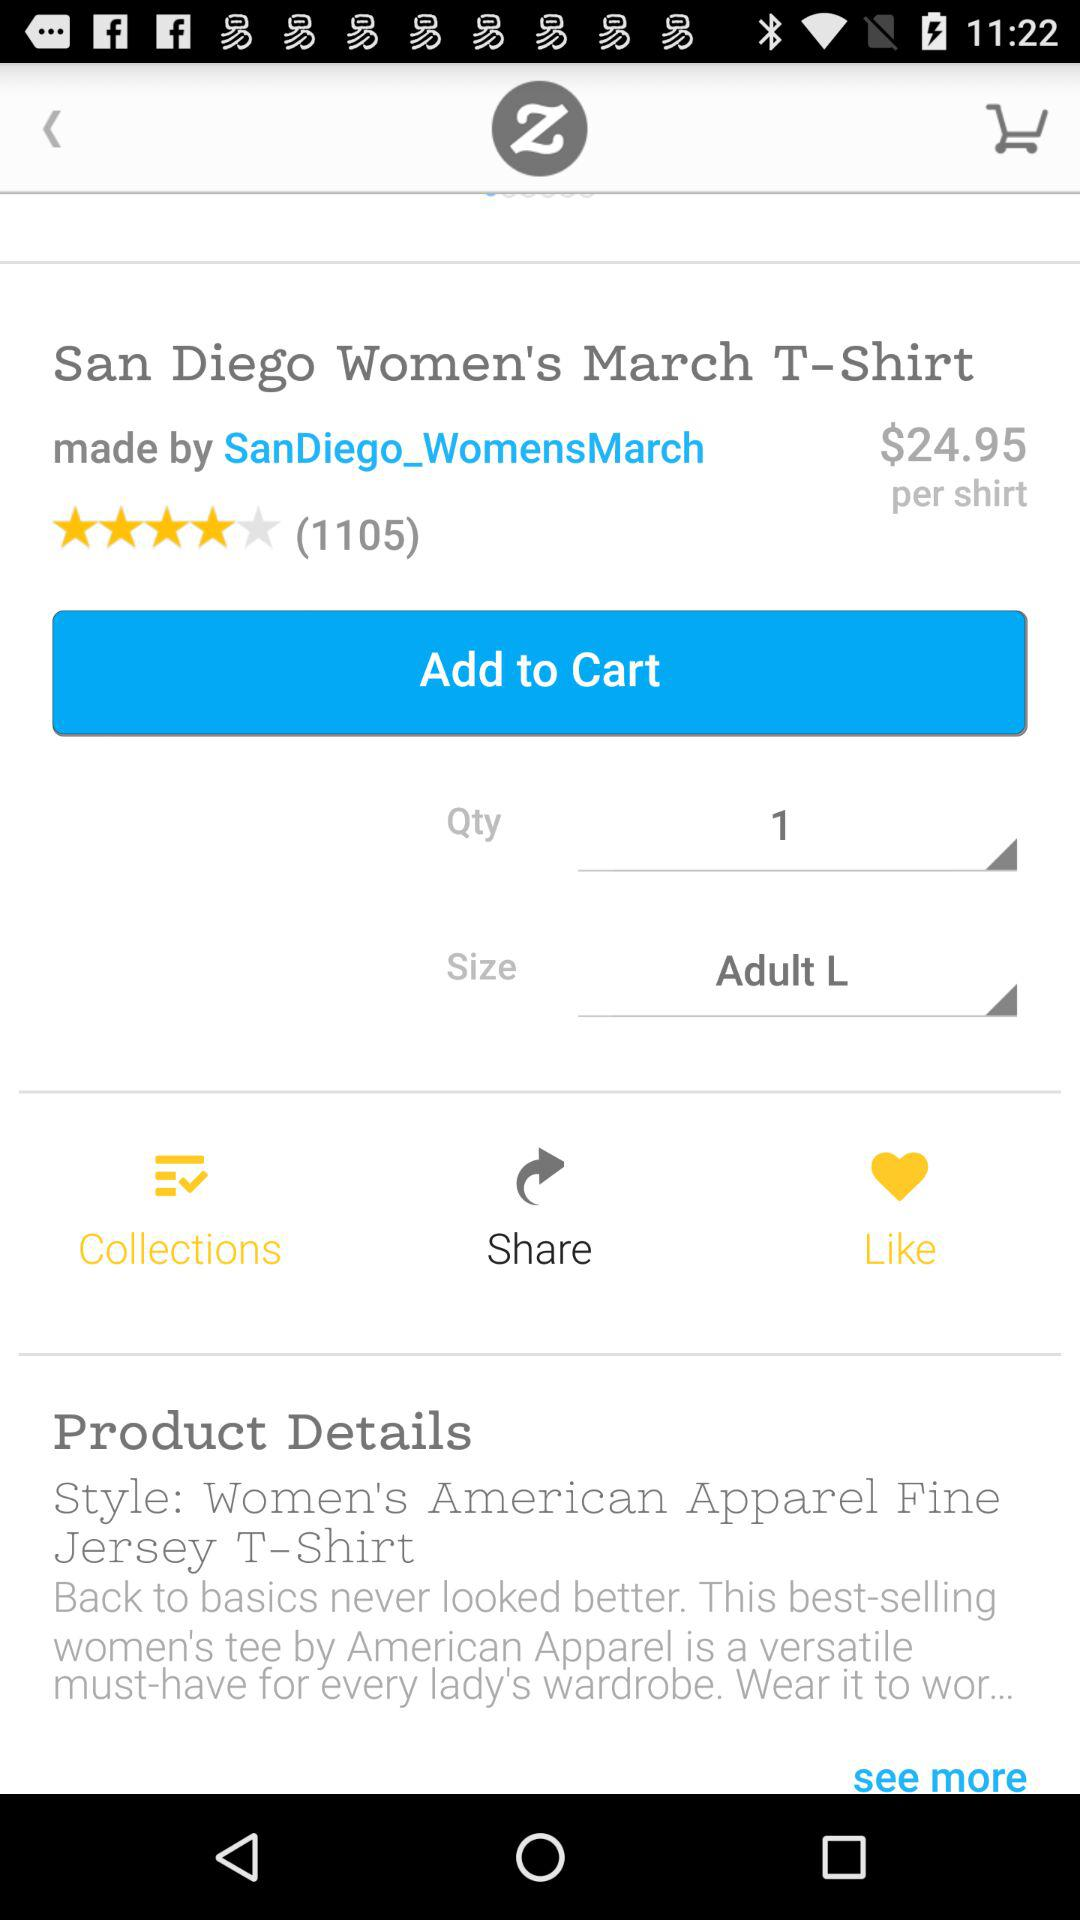What's the quantity? The quantity is 1. 